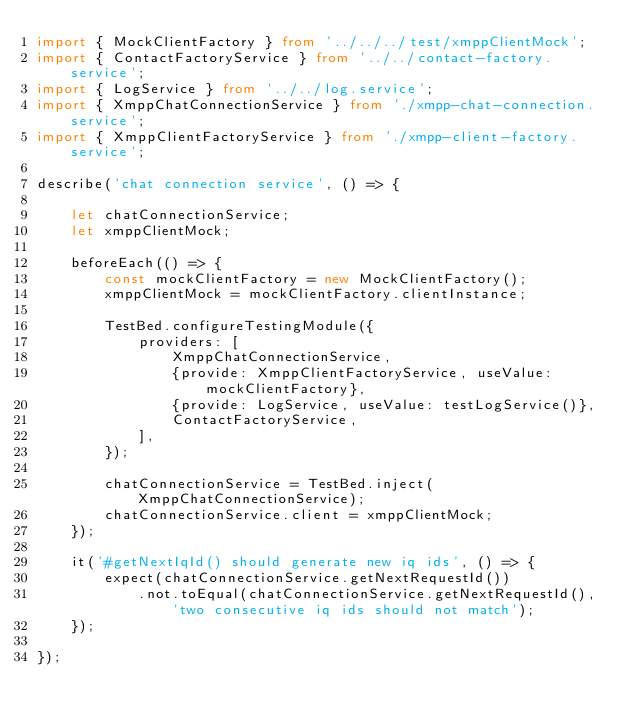<code> <loc_0><loc_0><loc_500><loc_500><_TypeScript_>import { MockClientFactory } from '../../../test/xmppClientMock';
import { ContactFactoryService } from '../../contact-factory.service';
import { LogService } from '../../log.service';
import { XmppChatConnectionService } from './xmpp-chat-connection.service';
import { XmppClientFactoryService } from './xmpp-client-factory.service';

describe('chat connection service', () => {

    let chatConnectionService;
    let xmppClientMock;

    beforeEach(() => {
        const mockClientFactory = new MockClientFactory();
        xmppClientMock = mockClientFactory.clientInstance;

        TestBed.configureTestingModule({
            providers: [
                XmppChatConnectionService,
                {provide: XmppClientFactoryService, useValue: mockClientFactory},
                {provide: LogService, useValue: testLogService()},
                ContactFactoryService,
            ],
        });

        chatConnectionService = TestBed.inject(XmppChatConnectionService);
        chatConnectionService.client = xmppClientMock;
    });

    it('#getNextIqId() should generate new iq ids', () => {
        expect(chatConnectionService.getNextRequestId())
            .not.toEqual(chatConnectionService.getNextRequestId(), 'two consecutive iq ids should not match');
    });

});
</code> 